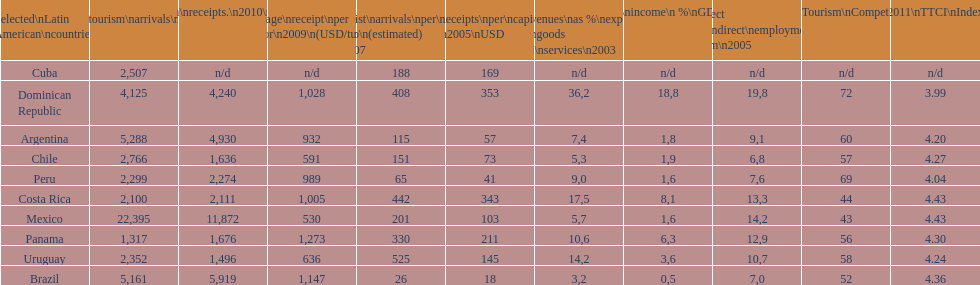Tourism income in latin american countries in 2003 was at most what percentage of gdp? 18,8. 